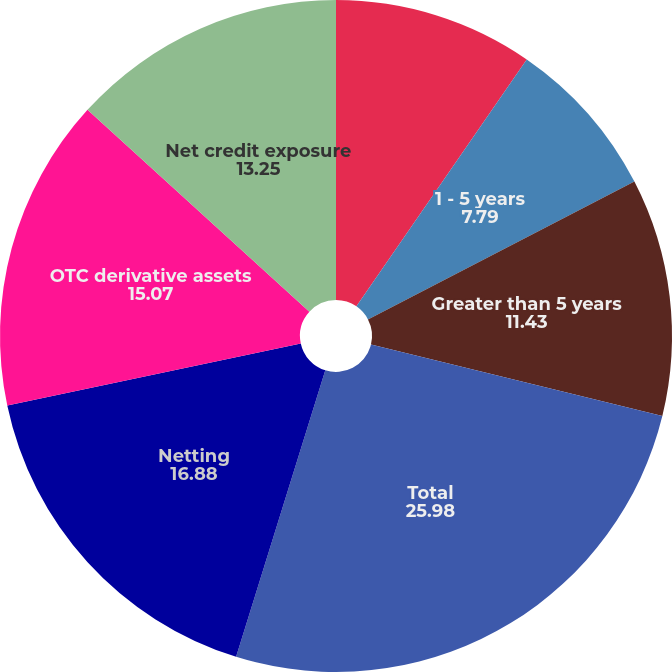Convert chart. <chart><loc_0><loc_0><loc_500><loc_500><pie_chart><fcel>Less than 1 year<fcel>1 - 5 years<fcel>Greater than 5 years<fcel>Total<fcel>Netting<fcel>OTC derivative assets<fcel>Net credit exposure<nl><fcel>9.61%<fcel>7.79%<fcel>11.43%<fcel>25.98%<fcel>16.88%<fcel>15.07%<fcel>13.25%<nl></chart> 